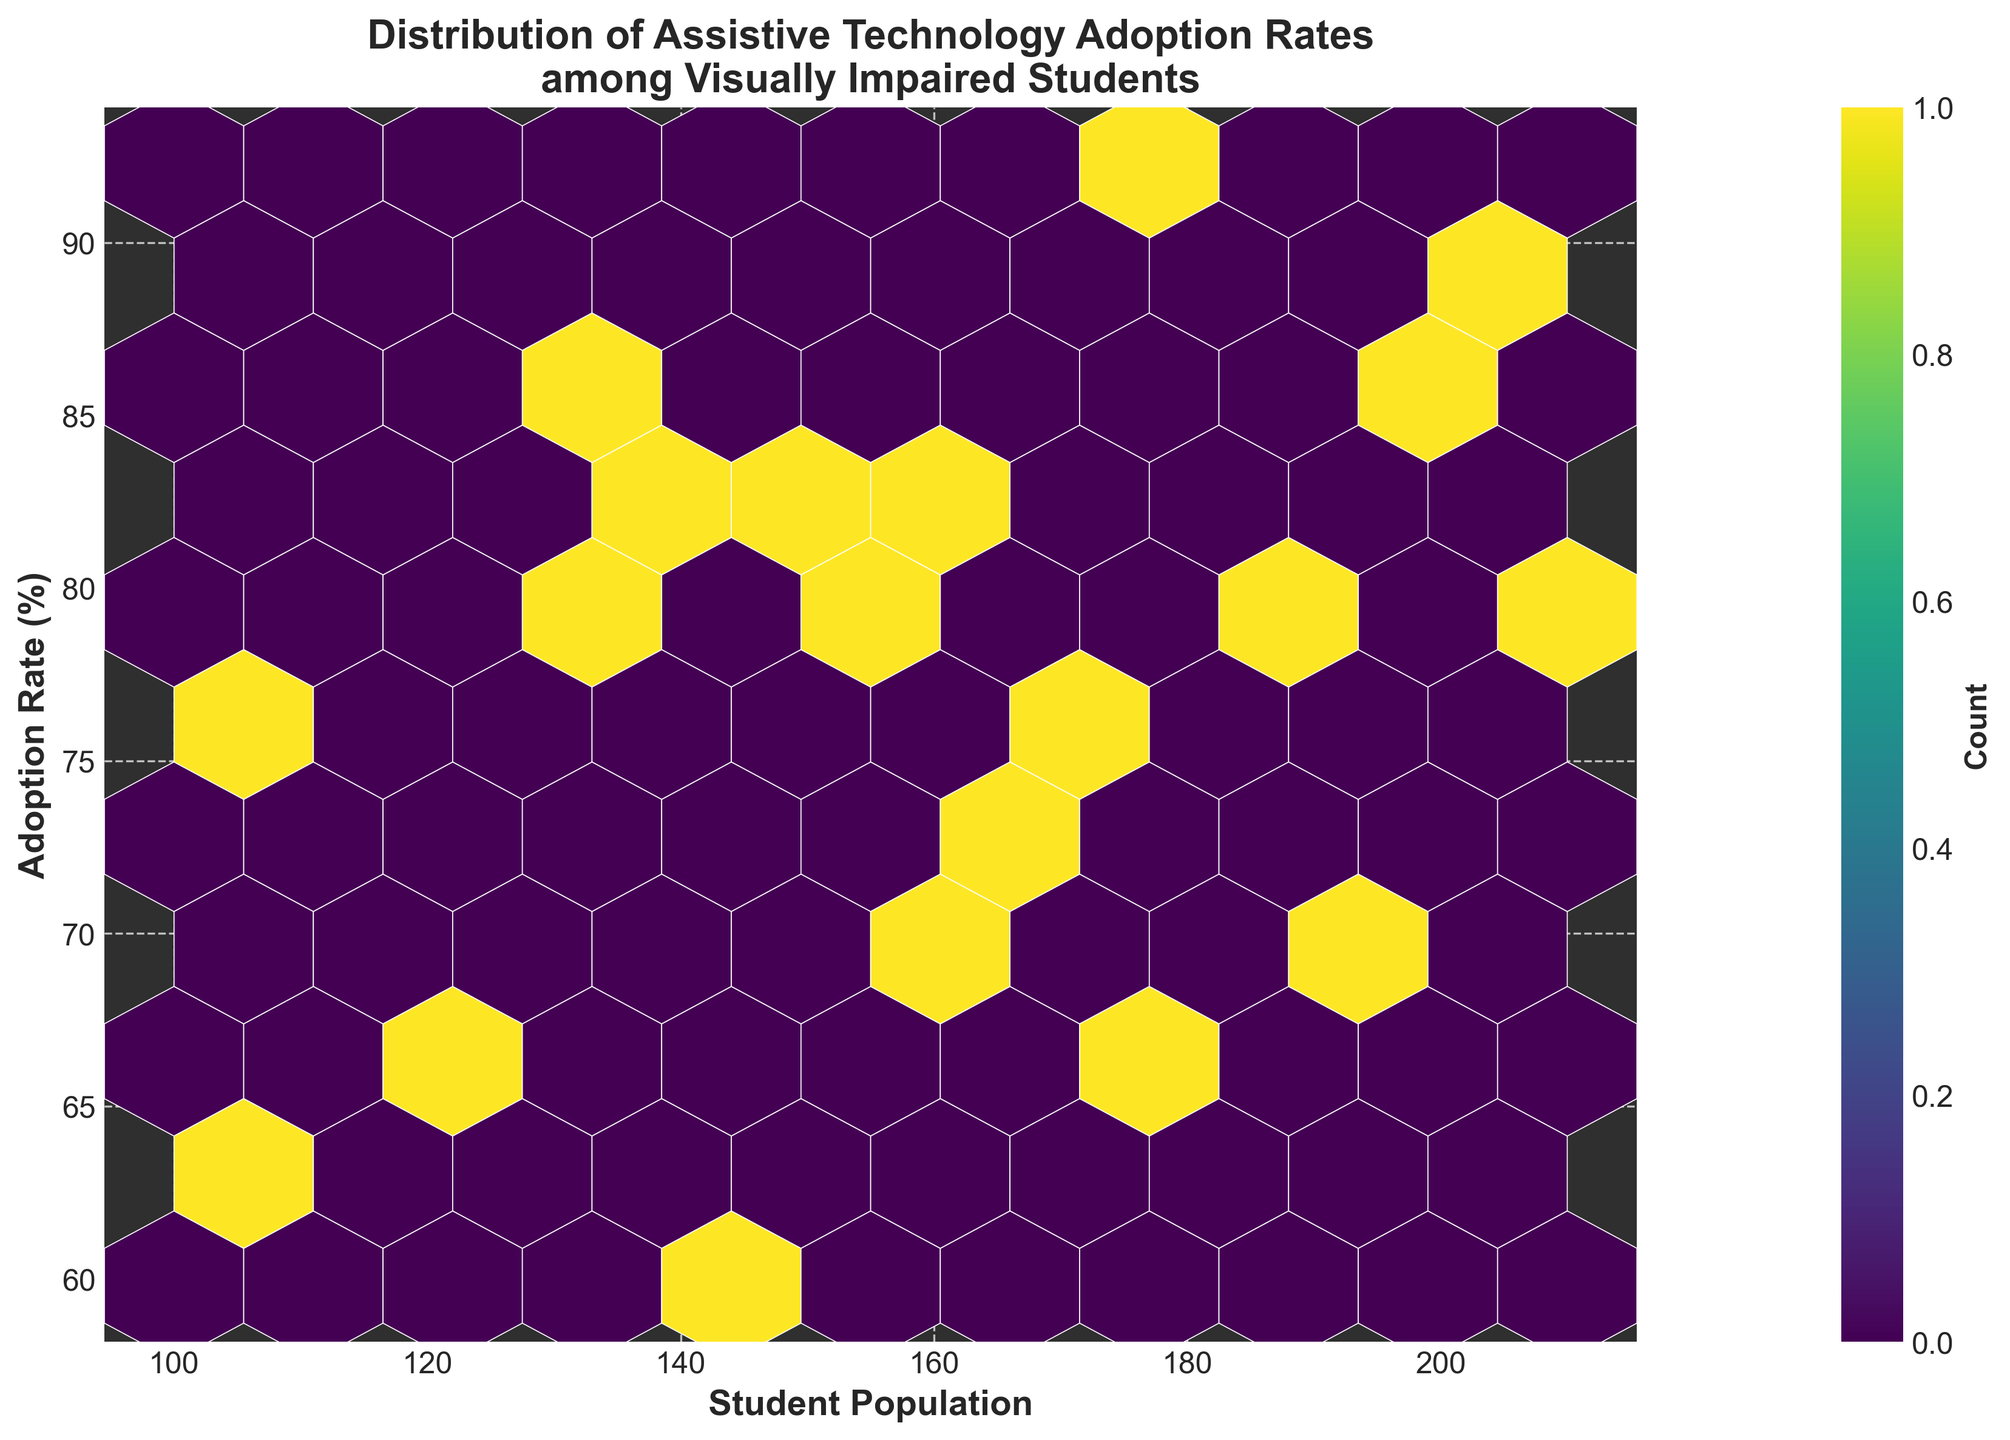What is the title of the figure? The title of a plot usually appears at the top and provides an overview of what the plot is about. In this case, the title is directly mentioned in the code used to generate the plot through the `ax.set_title` function, which sets the title as 'Distribution of Assistive Technology Adoption Rates among Visually Impaired Students'.
Answer: Distribution of Assistive Technology Adoption Rates among Visually Impaired Students What are the axes labels? The axes labels provide information about what each axis represents. In this figure, the `set_xlabel` and `set_ylabel` functions in the code specify the labels. The horizontal axis represents 'Student Population' and the vertical axis represents 'Adoption Rate (%)'.
Answer: Student Population (x-axis) and Adoption Rate (%) (y-axis) Which color scheme is used in the hexbin plot? The color scheme or colormap for the hexbin plot is specified in the code with the `cmap` parameter. In this plot, the colormap 'viridis' is used, which ranges from purple to yellow.
Answer: Viridis How many bins have the highest count of institutions? To answer this, one needs to observe the color bar, which indicates the count mapping to colors on the hexbin plot. Although the exact count cannot be determined just from the plot without color references, the highest count bins would be the ones with the lightest color (yellow).
Answer: Bins with the lightest color What is the range of student populations represented in the plot? To determine the range of student populations, observe the x-axis values. The data provided includes institutions from 100 to 210 students.
Answer: 100 to 210 Which category on the plot has a noticeably lower adoption rate? By examining the y-axis and the spread of the data points, the institutions around lower y-axis values exhibit lower adoption rates. From the data, the University of São Paulo, University of Cape Town, and Peking University generally fall into this category.
Answer: University of São Paulo, University of Cape Town, Peking University What is the approximate average adoption rate visible in the plot? To find the average adoption rate visually from the hexbin plot, one can estimate the central tendency of the data spread along the y-axis. The data points seem to cluster around 70-85%.
Answer: ~75% What is the distribution trend between student population and adoption rate on the plot? By observing the plot, one can determine whether there's a trend, such as a positive or negative correlation. The points appear to show that as student population increases, the adoption rates are relatively high, suggesting a possible positive relationship.
Answer: Positive trend Which institution has the highest adoption rate of assistive technology? The highest adoption rate can be determined by identifying the highest y-value on the plot; according to the data, MIT has the highest adoption rate of 92.3%.
Answer: MIT 